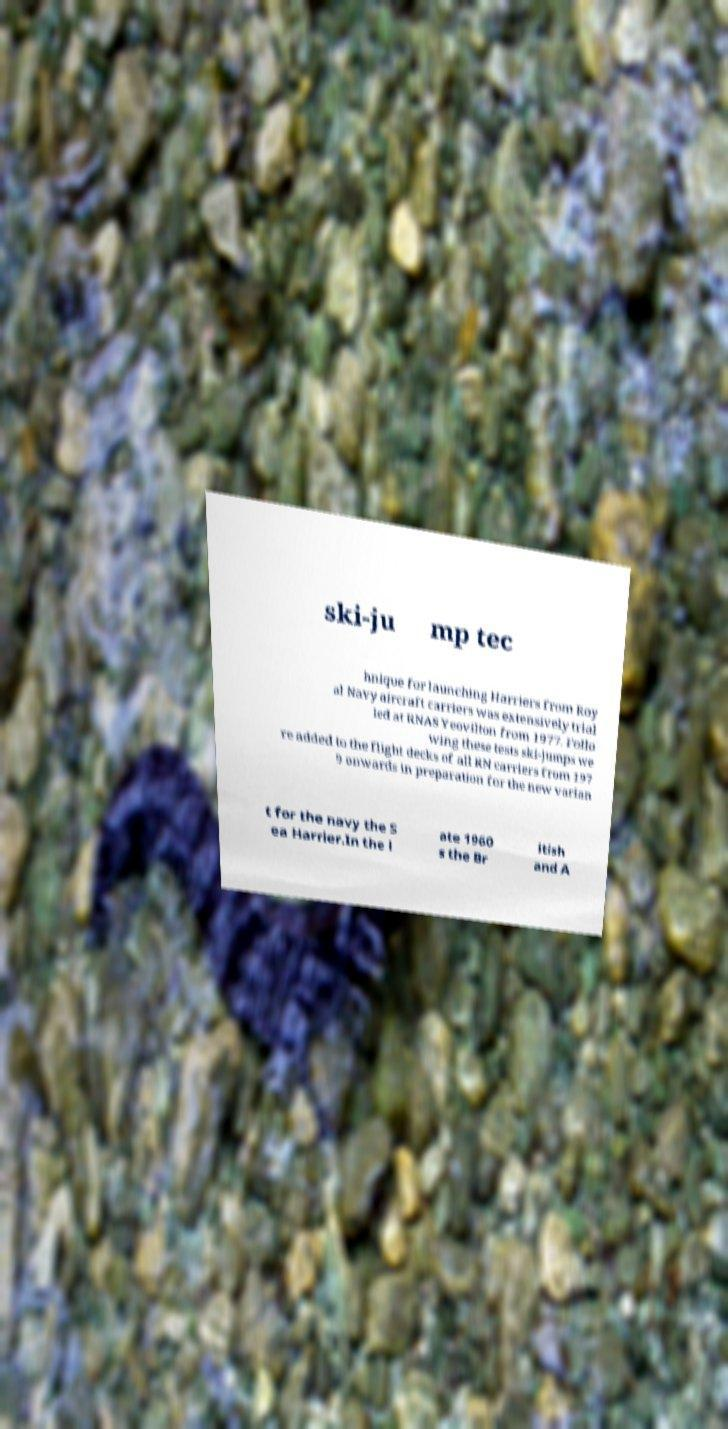Can you read and provide the text displayed in the image?This photo seems to have some interesting text. Can you extract and type it out for me? ski-ju mp tec hnique for launching Harriers from Roy al Navy aircraft carriers was extensively trial led at RNAS Yeovilton from 1977. Follo wing these tests ski-jumps we re added to the flight decks of all RN carriers from 197 9 onwards in preparation for the new varian t for the navy the S ea Harrier.In the l ate 1960 s the Br itish and A 